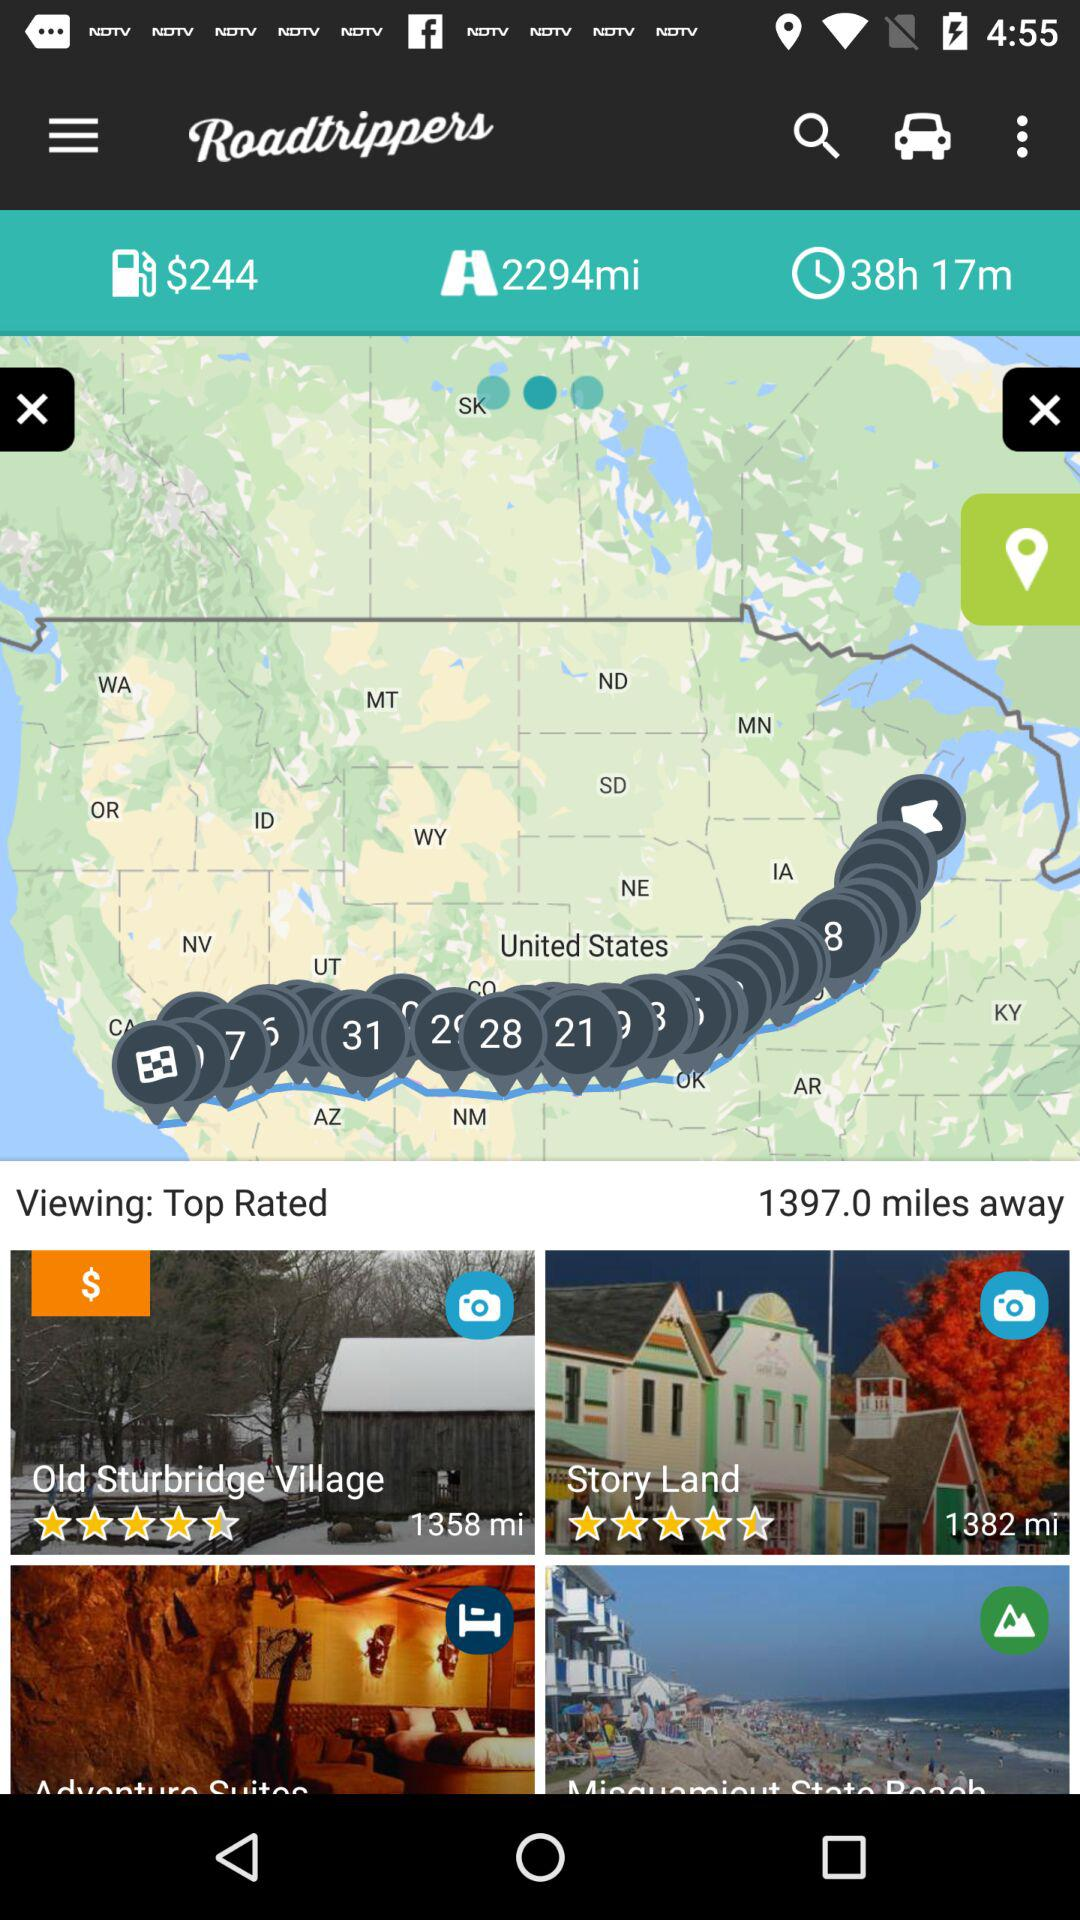What is the given total journey duration? The given total journey duration is 38 hours and 17 minutes. 